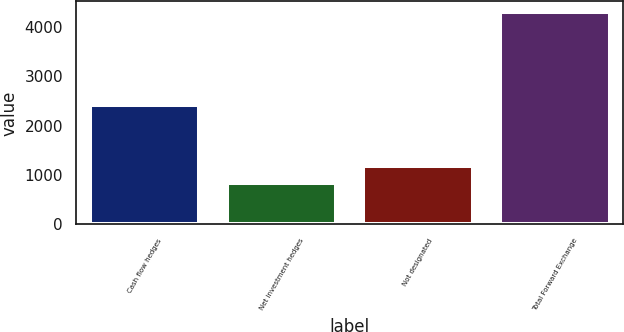Convert chart to OTSL. <chart><loc_0><loc_0><loc_500><loc_500><bar_chart><fcel>Cash flow hedges<fcel>Net investment hedges<fcel>Not designated<fcel>Total Forward Exchange<nl><fcel>2418.2<fcel>830.8<fcel>1177.97<fcel>4302.5<nl></chart> 